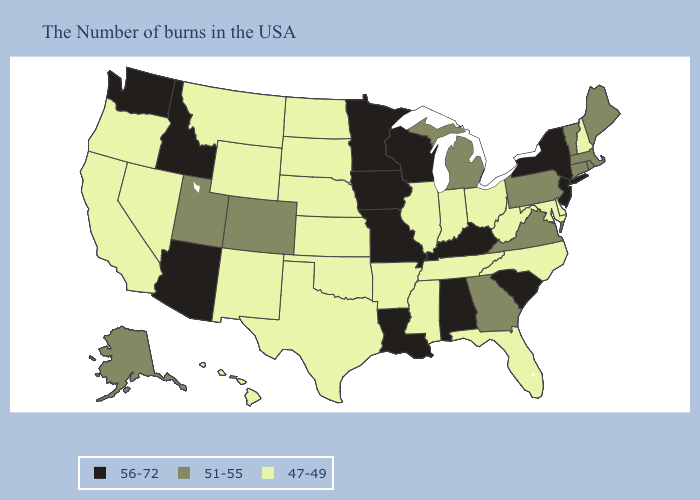What is the lowest value in states that border Georgia?
Give a very brief answer. 47-49. Does Arizona have a higher value than Arkansas?
Answer briefly. Yes. What is the highest value in the MidWest ?
Answer briefly. 56-72. Does California have the lowest value in the USA?
Write a very short answer. Yes. Among the states that border Arkansas , does Missouri have the lowest value?
Be succinct. No. Among the states that border Arizona , which have the lowest value?
Write a very short answer. New Mexico, Nevada, California. What is the value of Iowa?
Concise answer only. 56-72. Among the states that border Montana , which have the lowest value?
Keep it brief. South Dakota, North Dakota, Wyoming. What is the value of Hawaii?
Quick response, please. 47-49. Which states hav the highest value in the MidWest?
Quick response, please. Wisconsin, Missouri, Minnesota, Iowa. Among the states that border Montana , which have the lowest value?
Keep it brief. South Dakota, North Dakota, Wyoming. Does Idaho have a higher value than Virginia?
Concise answer only. Yes. Which states hav the highest value in the MidWest?
Short answer required. Wisconsin, Missouri, Minnesota, Iowa. Name the states that have a value in the range 56-72?
Answer briefly. New York, New Jersey, South Carolina, Kentucky, Alabama, Wisconsin, Louisiana, Missouri, Minnesota, Iowa, Arizona, Idaho, Washington. What is the lowest value in the USA?
Be succinct. 47-49. 